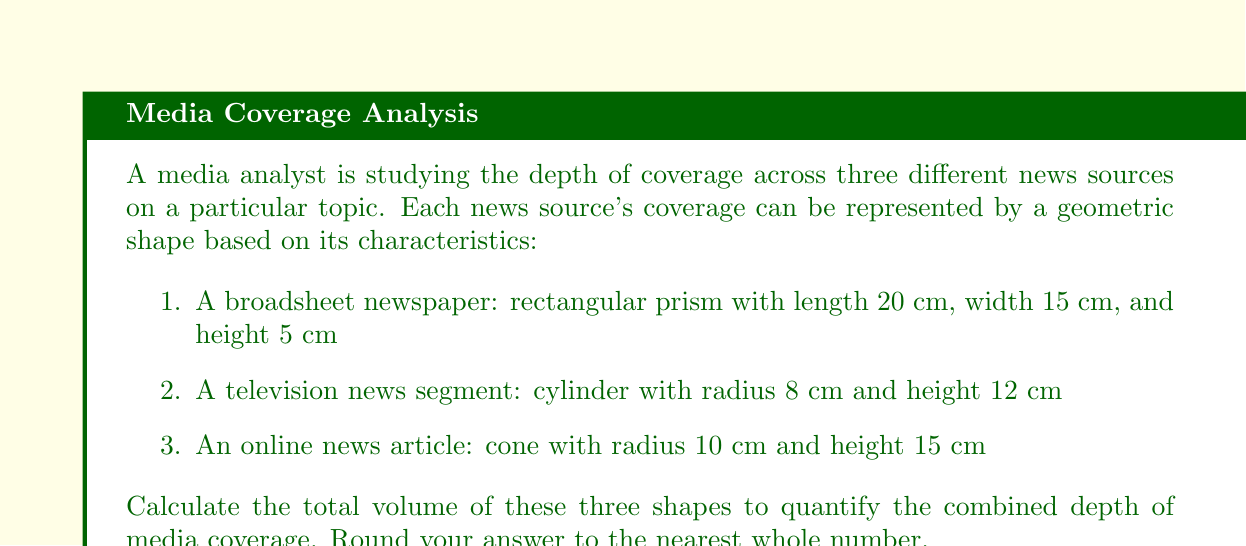Could you help me with this problem? To solve this problem, we need to calculate the volume of each shape and then sum them up:

1. Rectangular prism (broadsheet newspaper):
   Volume = length × width × height
   $$V_1 = 20 \times 15 \times 5 = 1500 \text{ cm}^3$$

2. Cylinder (television news segment):
   Volume = π × radius² × height
   $$V_2 = \pi \times 8^2 \times 12 = 2412.74 \text{ cm}^3$$

3. Cone (online news article):
   Volume = (1/3) × π × radius² × height
   $$V_3 = \frac{1}{3} \times \pi \times 10^2 \times 15 = 1570.80 \text{ cm}^3$$

Total volume:
$$V_{\text{total}} = V_1 + V_2 + V_3$$
$$V_{\text{total}} = 1500 + 2412.74 + 1570.80 = 5483.54 \text{ cm}^3$$

Rounding to the nearest whole number:
$$V_{\text{total}} \approx 5484 \text{ cm}^3$$
Answer: 5484 cm³ 